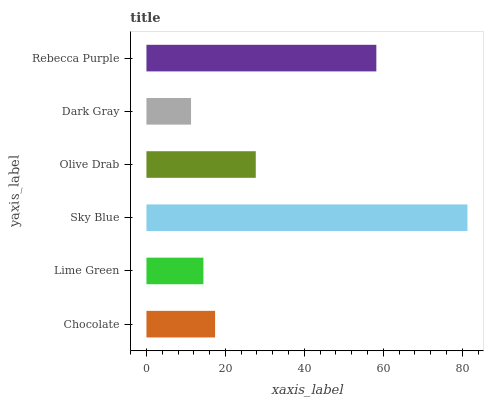Is Dark Gray the minimum?
Answer yes or no. Yes. Is Sky Blue the maximum?
Answer yes or no. Yes. Is Lime Green the minimum?
Answer yes or no. No. Is Lime Green the maximum?
Answer yes or no. No. Is Chocolate greater than Lime Green?
Answer yes or no. Yes. Is Lime Green less than Chocolate?
Answer yes or no. Yes. Is Lime Green greater than Chocolate?
Answer yes or no. No. Is Chocolate less than Lime Green?
Answer yes or no. No. Is Olive Drab the high median?
Answer yes or no. Yes. Is Chocolate the low median?
Answer yes or no. Yes. Is Chocolate the high median?
Answer yes or no. No. Is Sky Blue the low median?
Answer yes or no. No. 